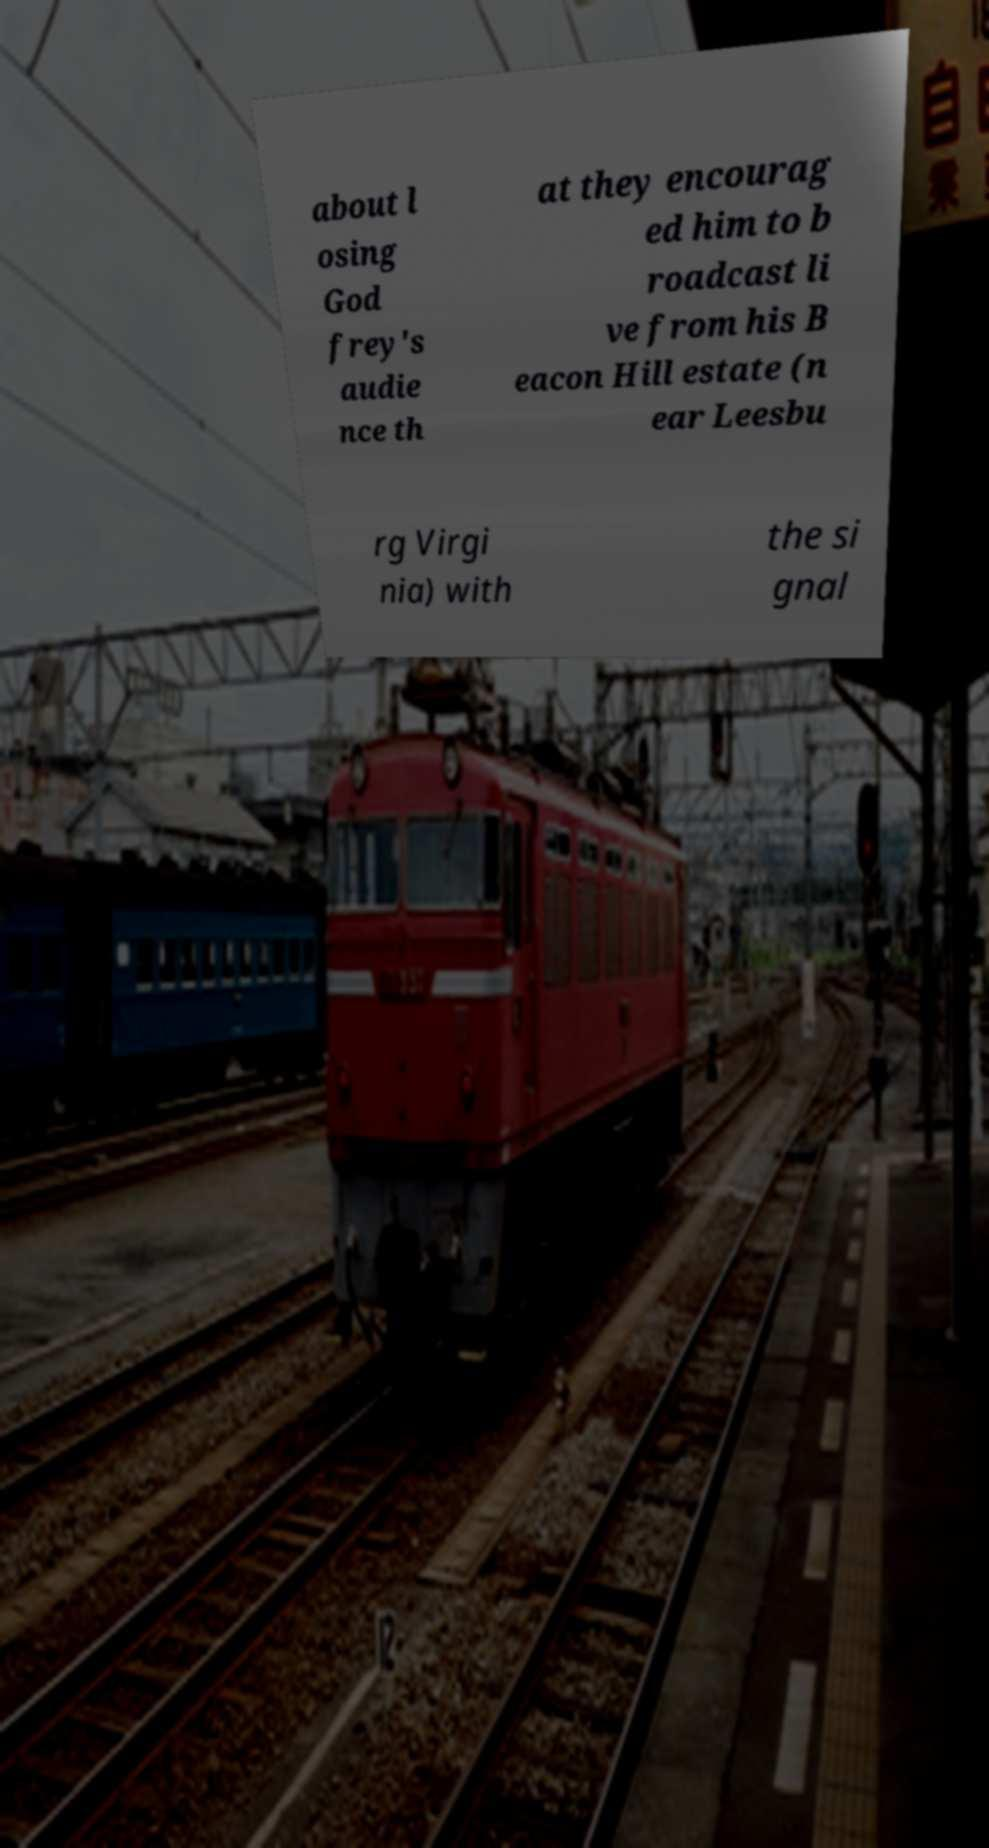Could you assist in decoding the text presented in this image and type it out clearly? about l osing God frey's audie nce th at they encourag ed him to b roadcast li ve from his B eacon Hill estate (n ear Leesbu rg Virgi nia) with the si gnal 